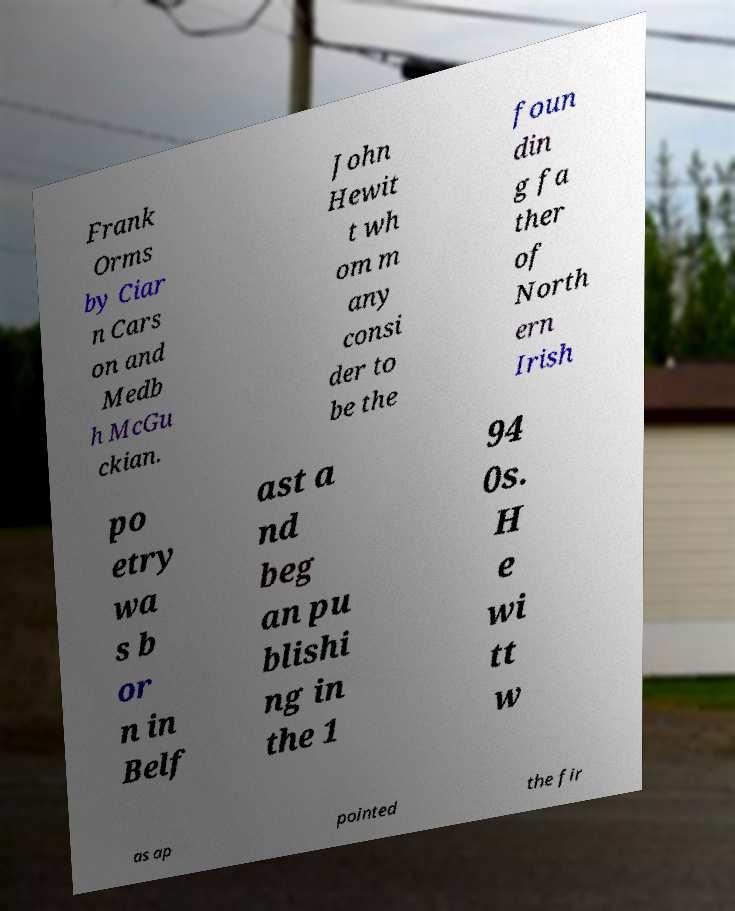Can you read and provide the text displayed in the image?This photo seems to have some interesting text. Can you extract and type it out for me? Frank Orms by Ciar n Cars on and Medb h McGu ckian. John Hewit t wh om m any consi der to be the foun din g fa ther of North ern Irish po etry wa s b or n in Belf ast a nd beg an pu blishi ng in the 1 94 0s. H e wi tt w as ap pointed the fir 